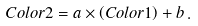Convert formula to latex. <formula><loc_0><loc_0><loc_500><loc_500>C o l o r 2 = a \times \left ( C o l o r 1 \right ) + b \, .</formula> 